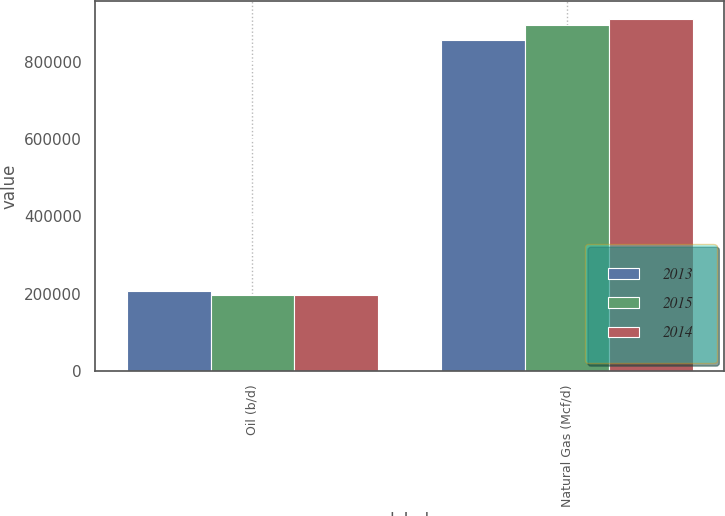Convert chart to OTSL. <chart><loc_0><loc_0><loc_500><loc_500><stacked_bar_chart><ecel><fcel>Oil (b/d)<fcel>Natural Gas (Mcf/d)<nl><fcel>2013<fcel>206501<fcel>856950<nl><fcel>2015<fcel>197366<fcel>894802<nl><fcel>2014<fcel>197622<fcel>912478<nl></chart> 